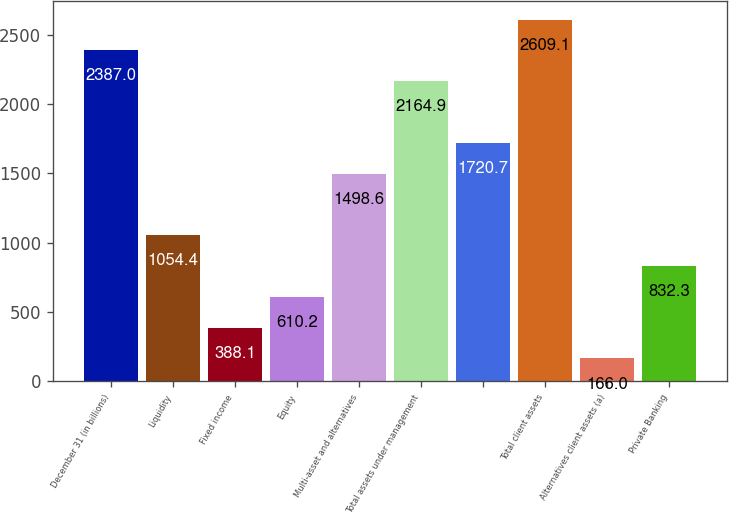<chart> <loc_0><loc_0><loc_500><loc_500><bar_chart><fcel>December 31 (in billions)<fcel>Liquidity<fcel>Fixed income<fcel>Equity<fcel>Multi-asset and alternatives<fcel>Total assets under management<fcel>Unnamed: 6<fcel>Total client assets<fcel>Alternatives client assets (a)<fcel>Private Banking<nl><fcel>2387<fcel>1054.4<fcel>388.1<fcel>610.2<fcel>1498.6<fcel>2164.9<fcel>1720.7<fcel>2609.1<fcel>166<fcel>832.3<nl></chart> 